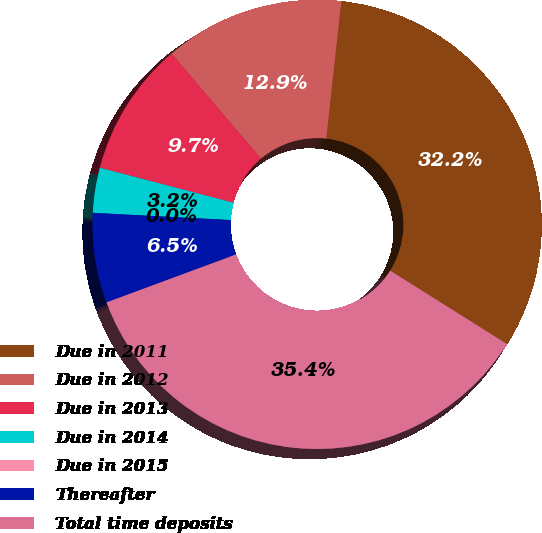<chart> <loc_0><loc_0><loc_500><loc_500><pie_chart><fcel>Due in 2011<fcel>Due in 2012<fcel>Due in 2013<fcel>Due in 2014<fcel>Due in 2015<fcel>Thereafter<fcel>Total time deposits<nl><fcel>32.2%<fcel>12.95%<fcel>9.71%<fcel>3.24%<fcel>0.0%<fcel>6.47%<fcel>35.43%<nl></chart> 